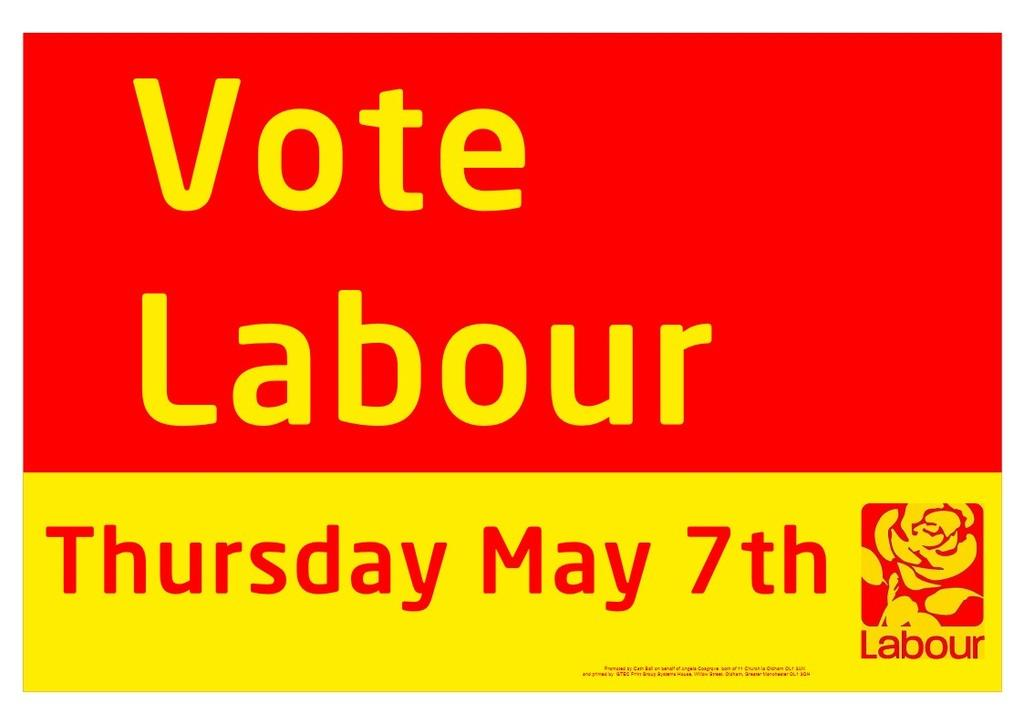<image>
Write a terse but informative summary of the picture. A red and yellow sign encourages people to vote labour. 